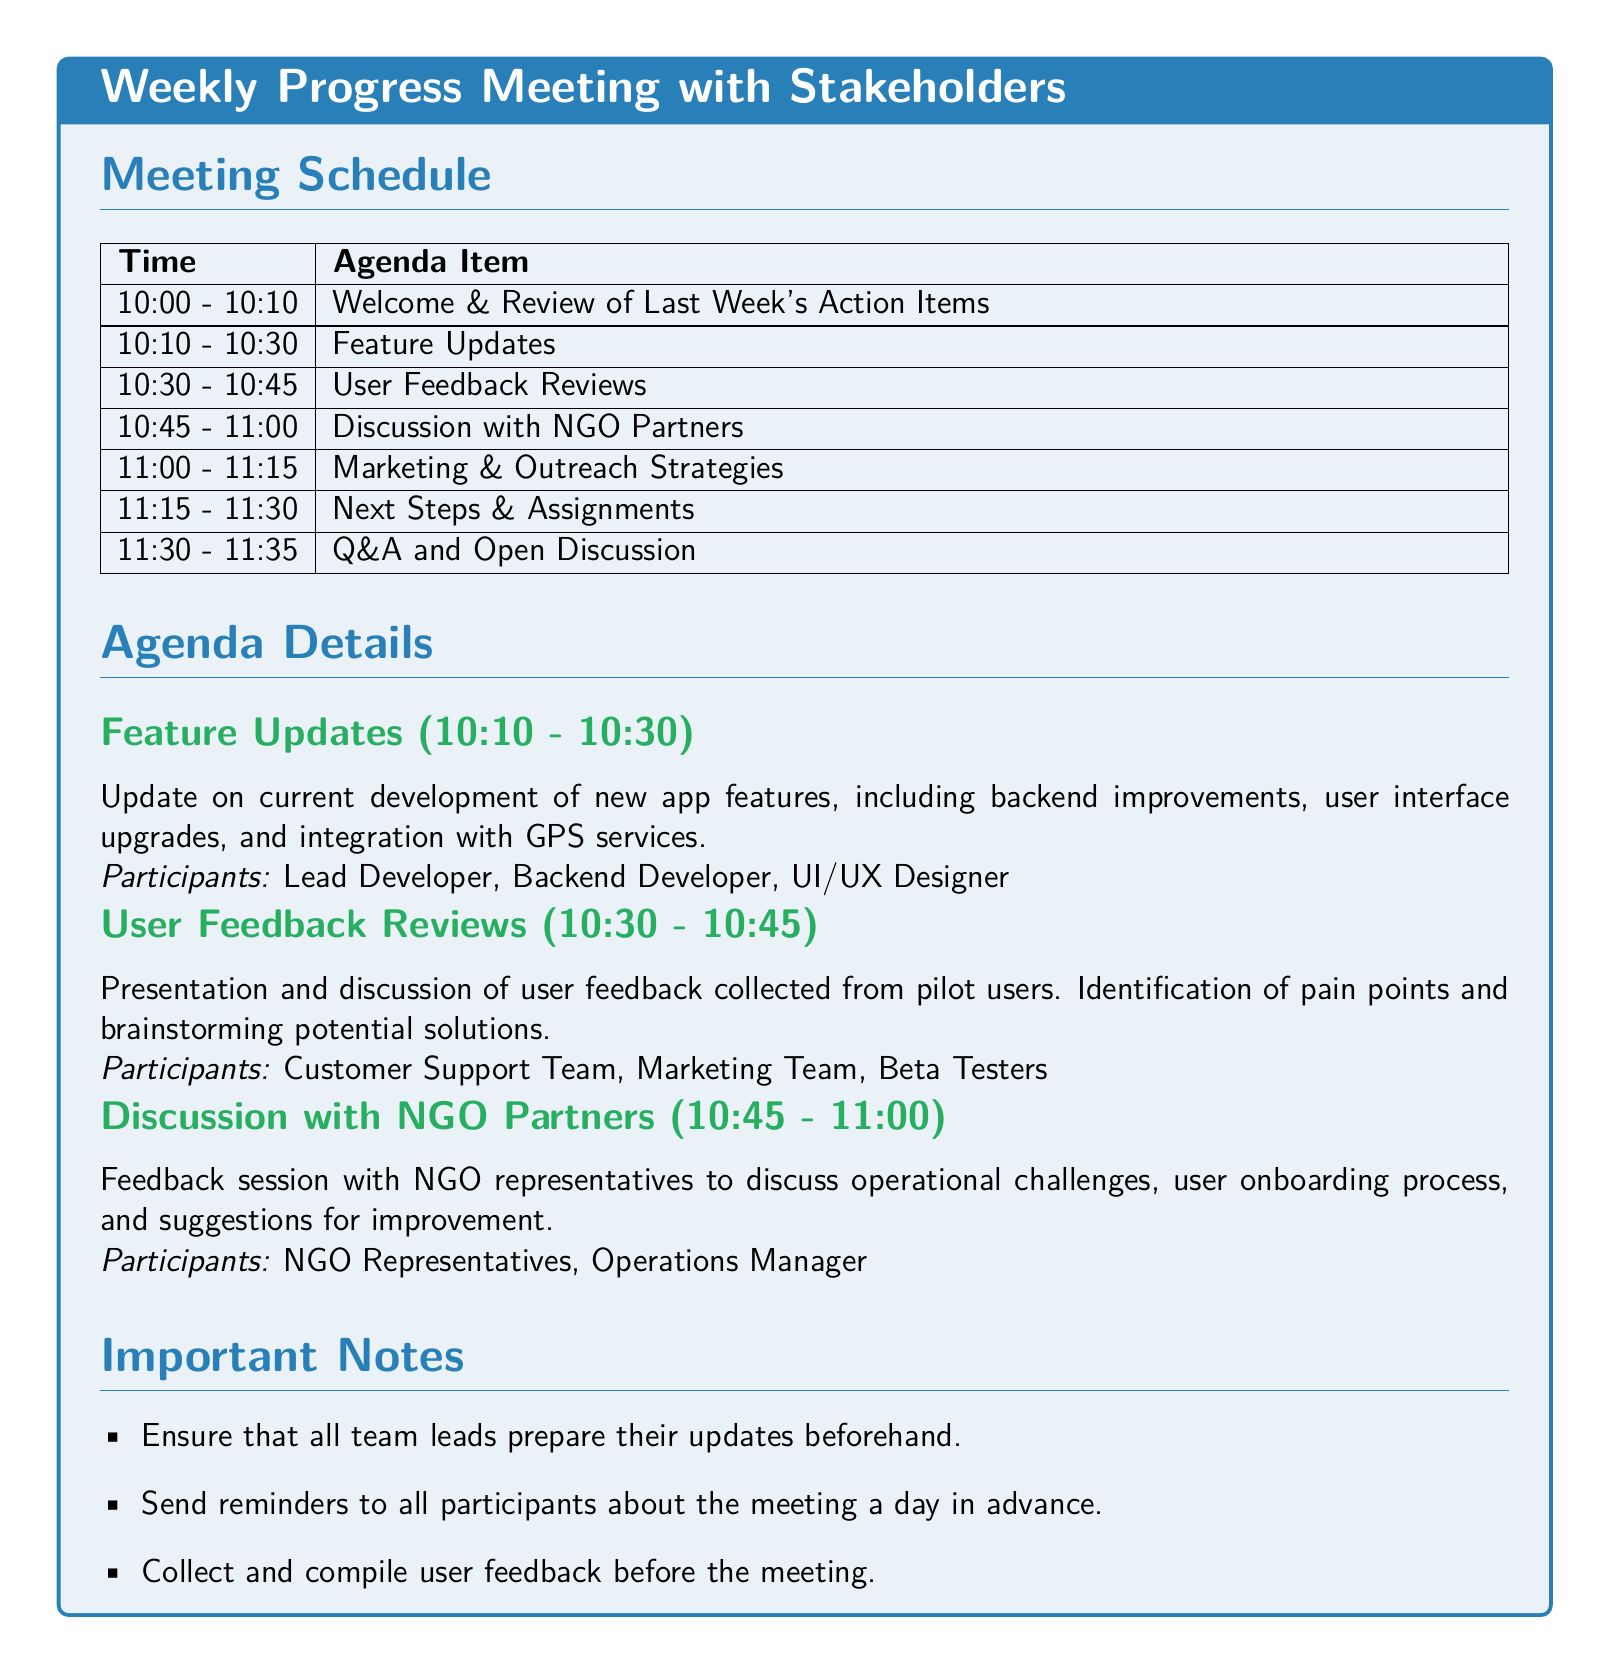What time does the meeting start? The meeting schedule begins at 10:00 AM.
Answer: 10:00 Who is responsible for providing the feature updates? The feature updates involve the Lead Developer, Backend Developer, and UI/UX Designer.
Answer: Lead Developer, Backend Developer, UI/UX Designer How long is the User Feedback Reviews session? The session for User Feedback Reviews is scheduled for 15 minutes.
Answer: 15 minutes What is the first agenda item? The first agenda item is the Welcome & Review of Last Week's Action Items.
Answer: Welcome & Review of Last Week's Action Items Which stakeholders are involved in the discussion with NGO partners? The participants in the discussion with NGO partners include NGO Representatives and the Operations Manager.
Answer: NGO Representatives, Operations Manager What is the last item on the agenda? The last item on the agenda is the Q&A and Open Discussion.
Answer: Q&A and Open Discussion What should be collected before the meeting? User feedback should be collected and compiled before the meeting.
Answer: User feedback How long does the Marketing & Outreach Strategies discussion last? The discussion on Marketing & Outreach Strategies lasts for 15 minutes.
Answer: 15 minutes 